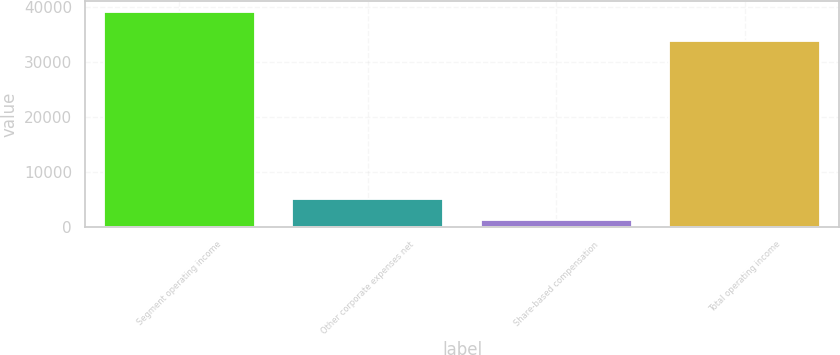Convert chart to OTSL. <chart><loc_0><loc_0><loc_500><loc_500><bar_chart><fcel>Segment operating income<fcel>Other corporate expenses net<fcel>Share-based compensation<fcel>Total operating income<nl><fcel>39060<fcel>4957.2<fcel>1168<fcel>33790<nl></chart> 